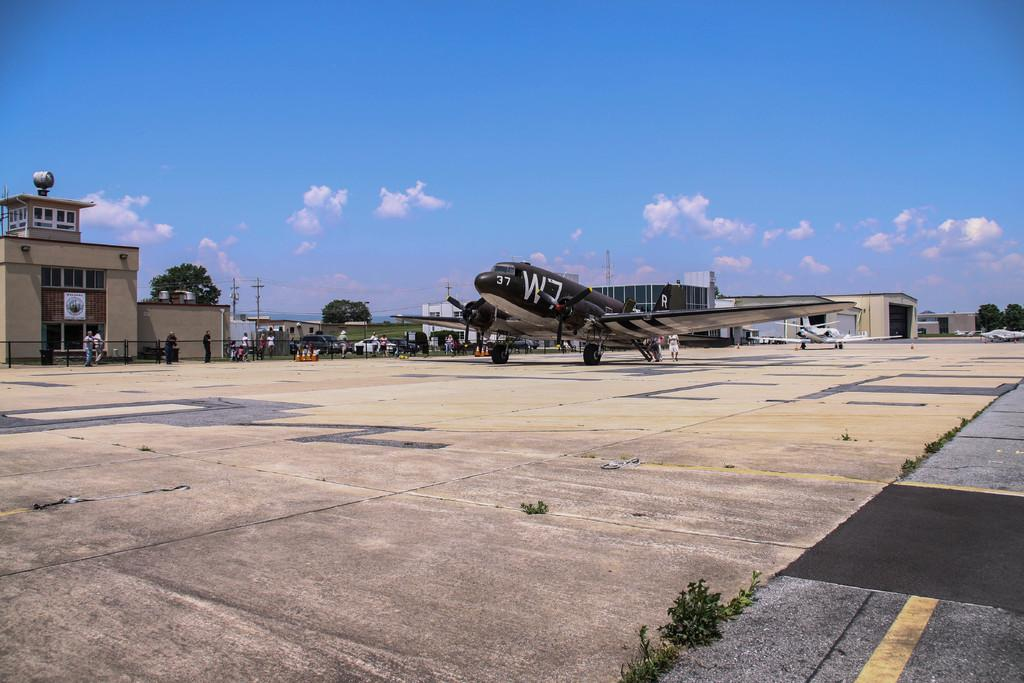<image>
Give a short and clear explanation of the subsequent image. A large propeller plane has the number 37 on it's nose. 